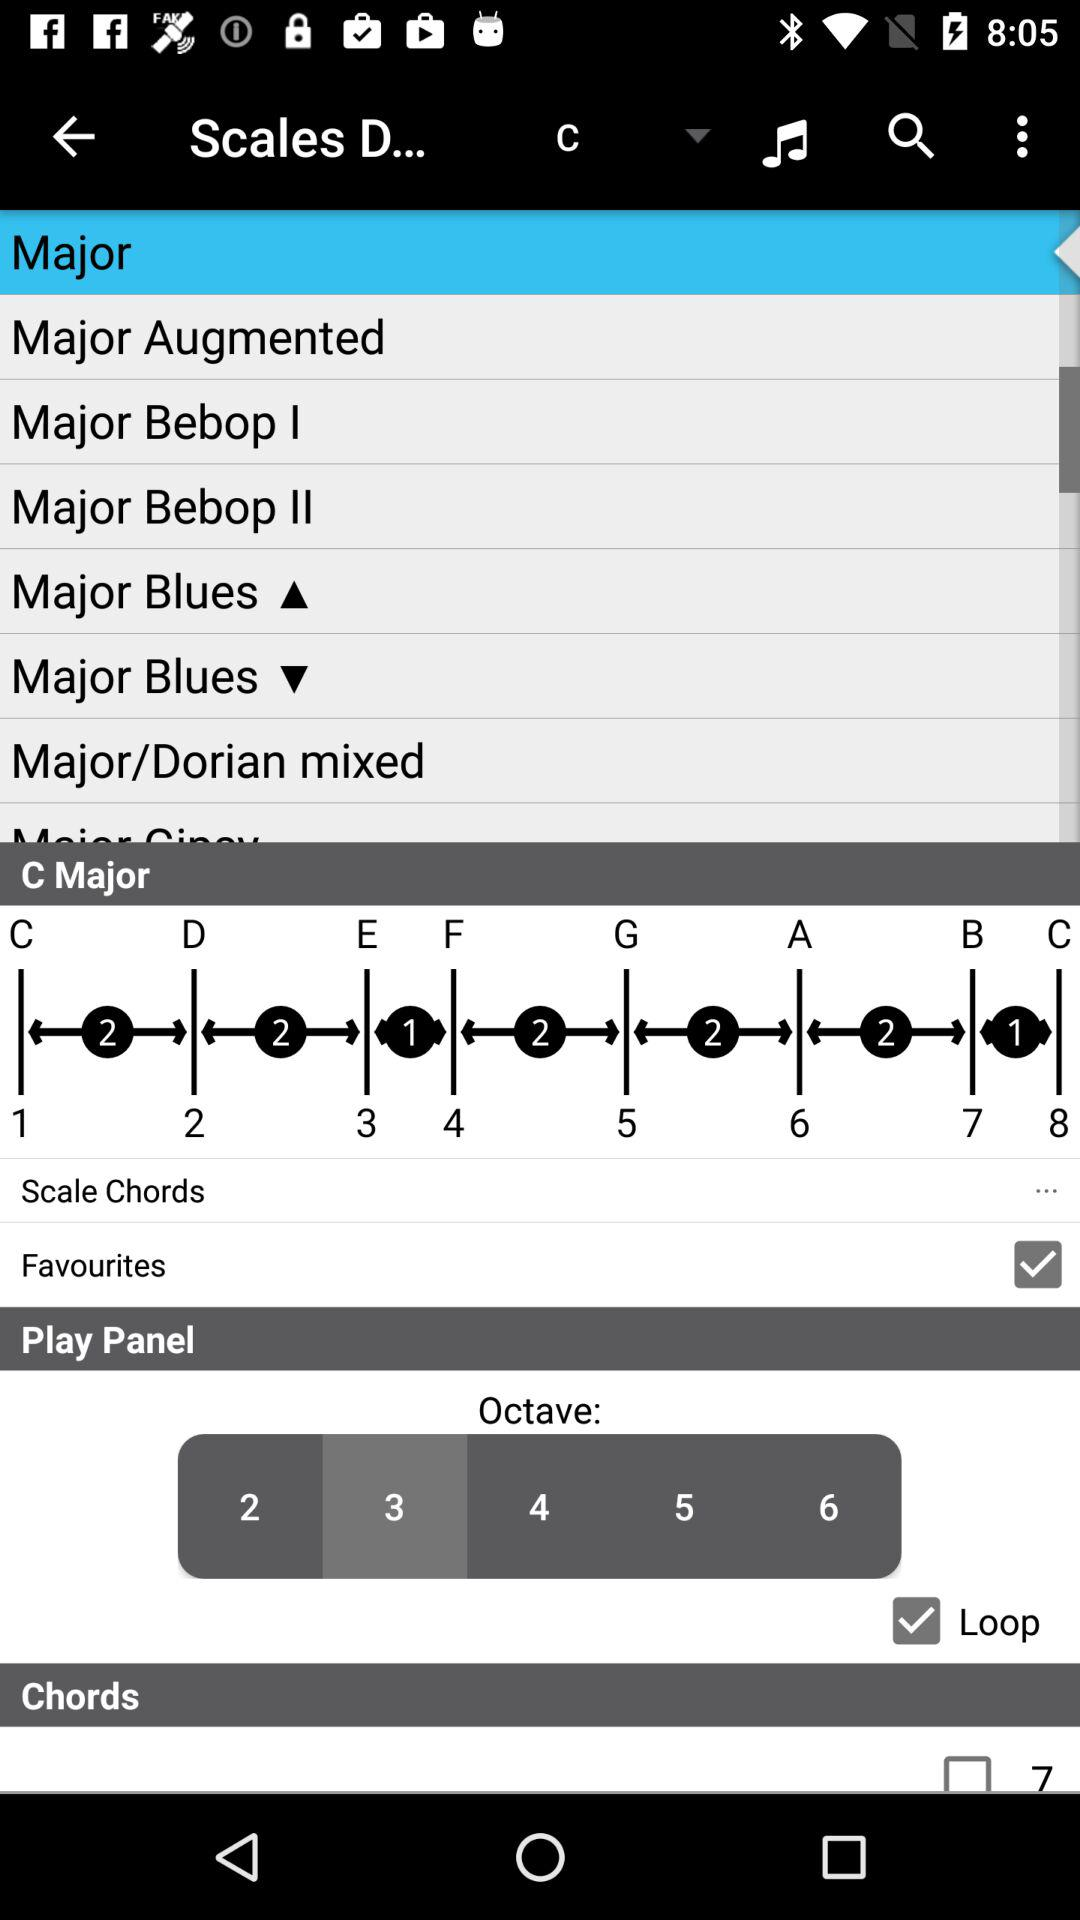What is the status of "Loop"? The status is "on". 